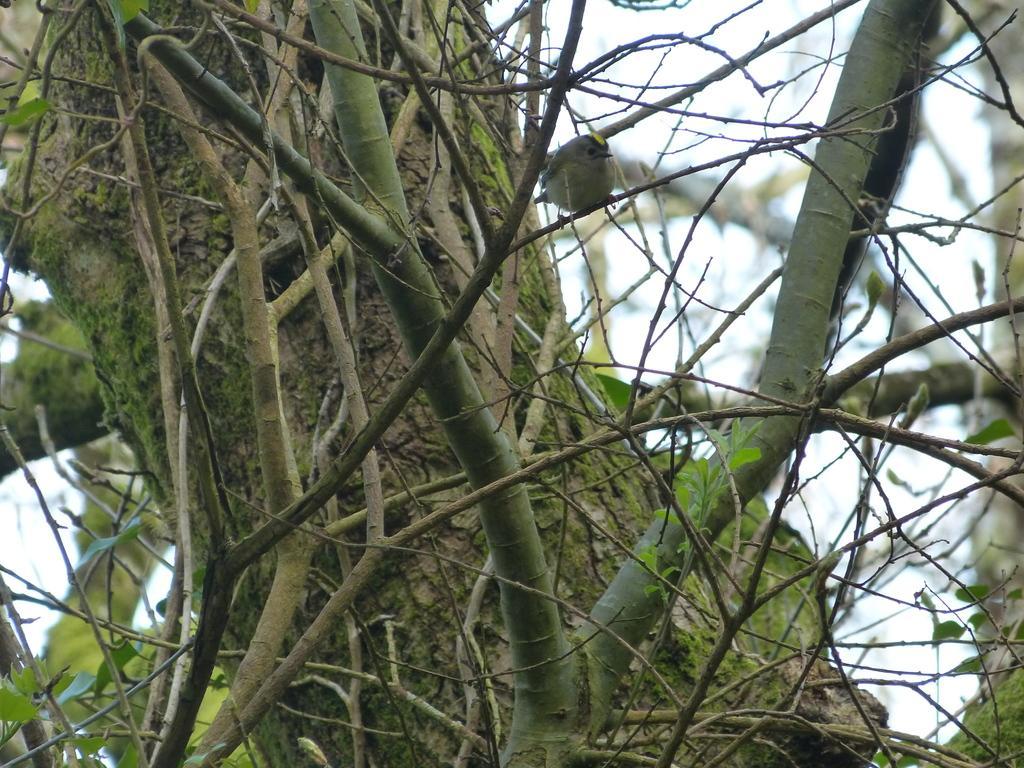Could you give a brief overview of what you see in this image? In this image in the front there are branches of tree. 